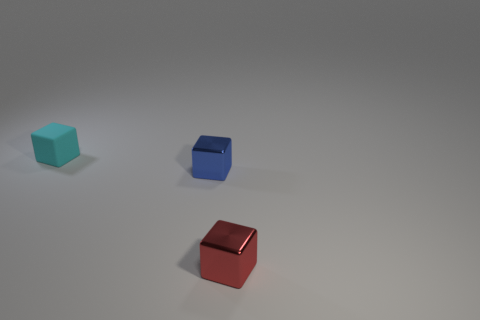There is another thing that is made of the same material as the tiny red thing; what is its color? The item that appears to be made of the same material as the small red object is the blue cube. Its surface reflects light similarly and has a matte finish, indicating that the two objects share the same material properties. 